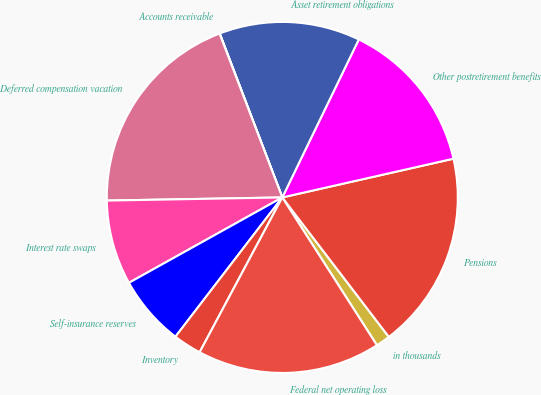Convert chart. <chart><loc_0><loc_0><loc_500><loc_500><pie_chart><fcel>in thousands<fcel>Pensions<fcel>Other postretirement benefits<fcel>Asset retirement obligations<fcel>Accounts receivable<fcel>Deferred compensation vacation<fcel>Interest rate swaps<fcel>Self-insurance reserves<fcel>Inventory<fcel>Federal net operating loss<nl><fcel>1.32%<fcel>18.16%<fcel>14.28%<fcel>12.98%<fcel>0.02%<fcel>19.46%<fcel>7.8%<fcel>6.5%<fcel>2.61%<fcel>16.87%<nl></chart> 